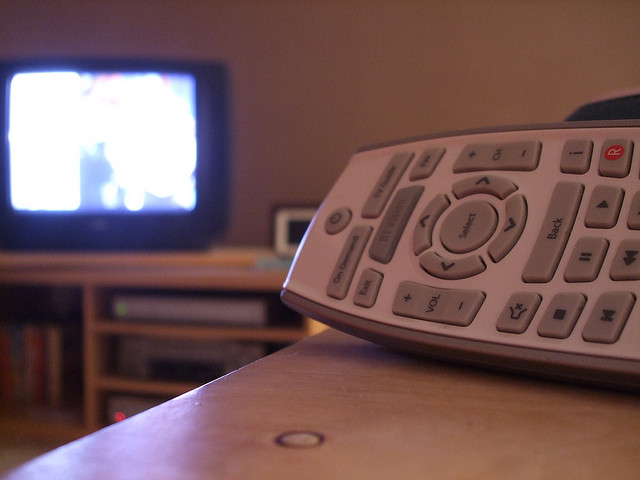Extract all visible text content from this image. VOL Back 